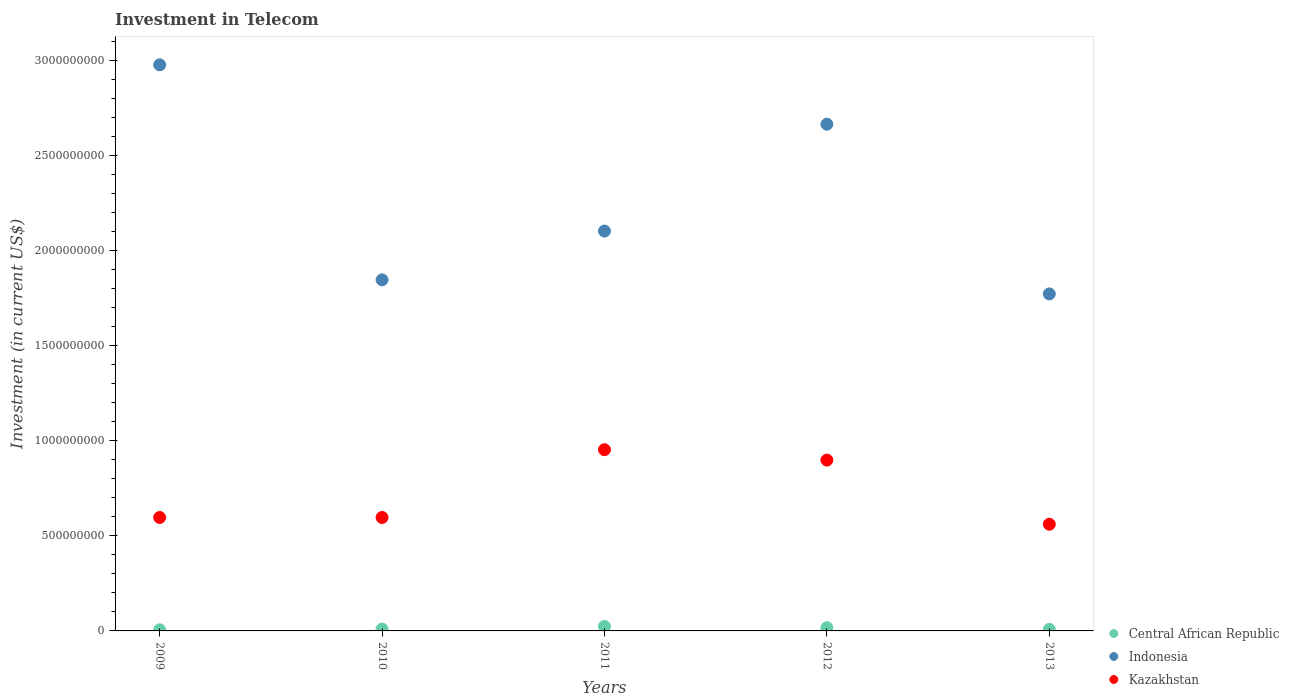Is the number of dotlines equal to the number of legend labels?
Your answer should be very brief. Yes. What is the amount invested in telecom in Central African Republic in 2012?
Offer a terse response. 1.70e+07. Across all years, what is the maximum amount invested in telecom in Central African Republic?
Provide a short and direct response. 2.39e+07. Across all years, what is the minimum amount invested in telecom in Indonesia?
Provide a short and direct response. 1.77e+09. In which year was the amount invested in telecom in Indonesia maximum?
Provide a succinct answer. 2009. In which year was the amount invested in telecom in Central African Republic minimum?
Make the answer very short. 2009. What is the total amount invested in telecom in Central African Republic in the graph?
Your answer should be compact. 6.50e+07. What is the difference between the amount invested in telecom in Central African Republic in 2010 and that in 2011?
Give a very brief answer. -1.39e+07. What is the difference between the amount invested in telecom in Indonesia in 2009 and the amount invested in telecom in Kazakhstan in 2012?
Provide a short and direct response. 2.08e+09. What is the average amount invested in telecom in Kazakhstan per year?
Your answer should be compact. 7.21e+08. In the year 2011, what is the difference between the amount invested in telecom in Kazakhstan and amount invested in telecom in Indonesia?
Your response must be concise. -1.15e+09. What is the ratio of the amount invested in telecom in Central African Republic in 2009 to that in 2011?
Make the answer very short. 0.25. Is the amount invested in telecom in Indonesia in 2012 less than that in 2013?
Keep it short and to the point. No. Is the difference between the amount invested in telecom in Kazakhstan in 2009 and 2011 greater than the difference between the amount invested in telecom in Indonesia in 2009 and 2011?
Your answer should be very brief. No. What is the difference between the highest and the second highest amount invested in telecom in Kazakhstan?
Your answer should be very brief. 5.45e+07. What is the difference between the highest and the lowest amount invested in telecom in Kazakhstan?
Your response must be concise. 3.92e+08. Is the amount invested in telecom in Kazakhstan strictly greater than the amount invested in telecom in Central African Republic over the years?
Your answer should be compact. Yes. Is the amount invested in telecom in Indonesia strictly less than the amount invested in telecom in Central African Republic over the years?
Your response must be concise. No. How many dotlines are there?
Ensure brevity in your answer.  3. Does the graph contain grids?
Make the answer very short. No. Where does the legend appear in the graph?
Offer a very short reply. Bottom right. How many legend labels are there?
Provide a short and direct response. 3. How are the legend labels stacked?
Offer a terse response. Vertical. What is the title of the graph?
Keep it short and to the point. Investment in Telecom. What is the label or title of the Y-axis?
Provide a succinct answer. Investment (in current US$). What is the Investment (in current US$) of Central African Republic in 2009?
Keep it short and to the point. 6.00e+06. What is the Investment (in current US$) in Indonesia in 2009?
Your answer should be compact. 2.98e+09. What is the Investment (in current US$) in Kazakhstan in 2009?
Give a very brief answer. 5.96e+08. What is the Investment (in current US$) of Indonesia in 2010?
Make the answer very short. 1.85e+09. What is the Investment (in current US$) of Kazakhstan in 2010?
Give a very brief answer. 5.96e+08. What is the Investment (in current US$) in Central African Republic in 2011?
Provide a short and direct response. 2.39e+07. What is the Investment (in current US$) of Indonesia in 2011?
Your answer should be compact. 2.10e+09. What is the Investment (in current US$) of Kazakhstan in 2011?
Provide a succinct answer. 9.53e+08. What is the Investment (in current US$) of Central African Republic in 2012?
Ensure brevity in your answer.  1.70e+07. What is the Investment (in current US$) of Indonesia in 2012?
Make the answer very short. 2.66e+09. What is the Investment (in current US$) of Kazakhstan in 2012?
Keep it short and to the point. 8.98e+08. What is the Investment (in current US$) of Central African Republic in 2013?
Your response must be concise. 8.10e+06. What is the Investment (in current US$) in Indonesia in 2013?
Provide a succinct answer. 1.77e+09. What is the Investment (in current US$) in Kazakhstan in 2013?
Ensure brevity in your answer.  5.61e+08. Across all years, what is the maximum Investment (in current US$) of Central African Republic?
Offer a very short reply. 2.39e+07. Across all years, what is the maximum Investment (in current US$) of Indonesia?
Your answer should be compact. 2.98e+09. Across all years, what is the maximum Investment (in current US$) of Kazakhstan?
Ensure brevity in your answer.  9.53e+08. Across all years, what is the minimum Investment (in current US$) of Central African Republic?
Offer a very short reply. 6.00e+06. Across all years, what is the minimum Investment (in current US$) in Indonesia?
Offer a very short reply. 1.77e+09. Across all years, what is the minimum Investment (in current US$) of Kazakhstan?
Provide a short and direct response. 5.61e+08. What is the total Investment (in current US$) of Central African Republic in the graph?
Your answer should be very brief. 6.50e+07. What is the total Investment (in current US$) in Indonesia in the graph?
Your answer should be very brief. 1.14e+1. What is the total Investment (in current US$) in Kazakhstan in the graph?
Your response must be concise. 3.60e+09. What is the difference between the Investment (in current US$) in Central African Republic in 2009 and that in 2010?
Make the answer very short. -4.00e+06. What is the difference between the Investment (in current US$) of Indonesia in 2009 and that in 2010?
Your answer should be very brief. 1.13e+09. What is the difference between the Investment (in current US$) in Central African Republic in 2009 and that in 2011?
Keep it short and to the point. -1.79e+07. What is the difference between the Investment (in current US$) in Indonesia in 2009 and that in 2011?
Your answer should be very brief. 8.74e+08. What is the difference between the Investment (in current US$) in Kazakhstan in 2009 and that in 2011?
Give a very brief answer. -3.56e+08. What is the difference between the Investment (in current US$) in Central African Republic in 2009 and that in 2012?
Ensure brevity in your answer.  -1.10e+07. What is the difference between the Investment (in current US$) of Indonesia in 2009 and that in 2012?
Make the answer very short. 3.12e+08. What is the difference between the Investment (in current US$) in Kazakhstan in 2009 and that in 2012?
Your answer should be very brief. -3.02e+08. What is the difference between the Investment (in current US$) of Central African Republic in 2009 and that in 2013?
Provide a succinct answer. -2.10e+06. What is the difference between the Investment (in current US$) of Indonesia in 2009 and that in 2013?
Your response must be concise. 1.20e+09. What is the difference between the Investment (in current US$) of Kazakhstan in 2009 and that in 2013?
Offer a terse response. 3.55e+07. What is the difference between the Investment (in current US$) of Central African Republic in 2010 and that in 2011?
Your answer should be very brief. -1.39e+07. What is the difference between the Investment (in current US$) of Indonesia in 2010 and that in 2011?
Offer a very short reply. -2.56e+08. What is the difference between the Investment (in current US$) in Kazakhstan in 2010 and that in 2011?
Provide a succinct answer. -3.56e+08. What is the difference between the Investment (in current US$) of Central African Republic in 2010 and that in 2012?
Ensure brevity in your answer.  -7.00e+06. What is the difference between the Investment (in current US$) in Indonesia in 2010 and that in 2012?
Make the answer very short. -8.18e+08. What is the difference between the Investment (in current US$) of Kazakhstan in 2010 and that in 2012?
Ensure brevity in your answer.  -3.02e+08. What is the difference between the Investment (in current US$) in Central African Republic in 2010 and that in 2013?
Give a very brief answer. 1.90e+06. What is the difference between the Investment (in current US$) of Indonesia in 2010 and that in 2013?
Your answer should be compact. 7.40e+07. What is the difference between the Investment (in current US$) of Kazakhstan in 2010 and that in 2013?
Keep it short and to the point. 3.55e+07. What is the difference between the Investment (in current US$) in Central African Republic in 2011 and that in 2012?
Provide a succinct answer. 6.90e+06. What is the difference between the Investment (in current US$) of Indonesia in 2011 and that in 2012?
Your response must be concise. -5.62e+08. What is the difference between the Investment (in current US$) of Kazakhstan in 2011 and that in 2012?
Your response must be concise. 5.45e+07. What is the difference between the Investment (in current US$) in Central African Republic in 2011 and that in 2013?
Offer a terse response. 1.58e+07. What is the difference between the Investment (in current US$) of Indonesia in 2011 and that in 2013?
Give a very brief answer. 3.30e+08. What is the difference between the Investment (in current US$) of Kazakhstan in 2011 and that in 2013?
Your answer should be very brief. 3.92e+08. What is the difference between the Investment (in current US$) in Central African Republic in 2012 and that in 2013?
Your answer should be very brief. 8.90e+06. What is the difference between the Investment (in current US$) in Indonesia in 2012 and that in 2013?
Your answer should be very brief. 8.92e+08. What is the difference between the Investment (in current US$) of Kazakhstan in 2012 and that in 2013?
Your answer should be compact. 3.37e+08. What is the difference between the Investment (in current US$) in Central African Republic in 2009 and the Investment (in current US$) in Indonesia in 2010?
Give a very brief answer. -1.84e+09. What is the difference between the Investment (in current US$) of Central African Republic in 2009 and the Investment (in current US$) of Kazakhstan in 2010?
Make the answer very short. -5.90e+08. What is the difference between the Investment (in current US$) in Indonesia in 2009 and the Investment (in current US$) in Kazakhstan in 2010?
Provide a short and direct response. 2.38e+09. What is the difference between the Investment (in current US$) in Central African Republic in 2009 and the Investment (in current US$) in Indonesia in 2011?
Provide a succinct answer. -2.10e+09. What is the difference between the Investment (in current US$) of Central African Republic in 2009 and the Investment (in current US$) of Kazakhstan in 2011?
Offer a very short reply. -9.47e+08. What is the difference between the Investment (in current US$) in Indonesia in 2009 and the Investment (in current US$) in Kazakhstan in 2011?
Offer a terse response. 2.02e+09. What is the difference between the Investment (in current US$) of Central African Republic in 2009 and the Investment (in current US$) of Indonesia in 2012?
Ensure brevity in your answer.  -2.66e+09. What is the difference between the Investment (in current US$) of Central African Republic in 2009 and the Investment (in current US$) of Kazakhstan in 2012?
Your response must be concise. -8.92e+08. What is the difference between the Investment (in current US$) of Indonesia in 2009 and the Investment (in current US$) of Kazakhstan in 2012?
Make the answer very short. 2.08e+09. What is the difference between the Investment (in current US$) of Central African Republic in 2009 and the Investment (in current US$) of Indonesia in 2013?
Your response must be concise. -1.77e+09. What is the difference between the Investment (in current US$) of Central African Republic in 2009 and the Investment (in current US$) of Kazakhstan in 2013?
Keep it short and to the point. -5.55e+08. What is the difference between the Investment (in current US$) of Indonesia in 2009 and the Investment (in current US$) of Kazakhstan in 2013?
Provide a succinct answer. 2.42e+09. What is the difference between the Investment (in current US$) of Central African Republic in 2010 and the Investment (in current US$) of Indonesia in 2011?
Provide a short and direct response. -2.09e+09. What is the difference between the Investment (in current US$) in Central African Republic in 2010 and the Investment (in current US$) in Kazakhstan in 2011?
Your answer should be very brief. -9.43e+08. What is the difference between the Investment (in current US$) in Indonesia in 2010 and the Investment (in current US$) in Kazakhstan in 2011?
Ensure brevity in your answer.  8.93e+08. What is the difference between the Investment (in current US$) of Central African Republic in 2010 and the Investment (in current US$) of Indonesia in 2012?
Provide a succinct answer. -2.65e+09. What is the difference between the Investment (in current US$) in Central African Republic in 2010 and the Investment (in current US$) in Kazakhstan in 2012?
Give a very brief answer. -8.88e+08. What is the difference between the Investment (in current US$) of Indonesia in 2010 and the Investment (in current US$) of Kazakhstan in 2012?
Your response must be concise. 9.47e+08. What is the difference between the Investment (in current US$) in Central African Republic in 2010 and the Investment (in current US$) in Indonesia in 2013?
Make the answer very short. -1.76e+09. What is the difference between the Investment (in current US$) of Central African Republic in 2010 and the Investment (in current US$) of Kazakhstan in 2013?
Offer a terse response. -5.51e+08. What is the difference between the Investment (in current US$) in Indonesia in 2010 and the Investment (in current US$) in Kazakhstan in 2013?
Give a very brief answer. 1.28e+09. What is the difference between the Investment (in current US$) of Central African Republic in 2011 and the Investment (in current US$) of Indonesia in 2012?
Your answer should be compact. -2.64e+09. What is the difference between the Investment (in current US$) of Central African Republic in 2011 and the Investment (in current US$) of Kazakhstan in 2012?
Ensure brevity in your answer.  -8.74e+08. What is the difference between the Investment (in current US$) of Indonesia in 2011 and the Investment (in current US$) of Kazakhstan in 2012?
Keep it short and to the point. 1.20e+09. What is the difference between the Investment (in current US$) of Central African Republic in 2011 and the Investment (in current US$) of Indonesia in 2013?
Your answer should be very brief. -1.75e+09. What is the difference between the Investment (in current US$) in Central African Republic in 2011 and the Investment (in current US$) in Kazakhstan in 2013?
Make the answer very short. -5.37e+08. What is the difference between the Investment (in current US$) of Indonesia in 2011 and the Investment (in current US$) of Kazakhstan in 2013?
Make the answer very short. 1.54e+09. What is the difference between the Investment (in current US$) in Central African Republic in 2012 and the Investment (in current US$) in Indonesia in 2013?
Ensure brevity in your answer.  -1.75e+09. What is the difference between the Investment (in current US$) in Central African Republic in 2012 and the Investment (in current US$) in Kazakhstan in 2013?
Offer a very short reply. -5.44e+08. What is the difference between the Investment (in current US$) of Indonesia in 2012 and the Investment (in current US$) of Kazakhstan in 2013?
Your answer should be compact. 2.10e+09. What is the average Investment (in current US$) of Central African Republic per year?
Offer a terse response. 1.30e+07. What is the average Investment (in current US$) of Indonesia per year?
Your answer should be very brief. 2.27e+09. What is the average Investment (in current US$) of Kazakhstan per year?
Your answer should be compact. 7.21e+08. In the year 2009, what is the difference between the Investment (in current US$) in Central African Republic and Investment (in current US$) in Indonesia?
Your response must be concise. -2.97e+09. In the year 2009, what is the difference between the Investment (in current US$) in Central African Republic and Investment (in current US$) in Kazakhstan?
Ensure brevity in your answer.  -5.90e+08. In the year 2009, what is the difference between the Investment (in current US$) in Indonesia and Investment (in current US$) in Kazakhstan?
Give a very brief answer. 2.38e+09. In the year 2010, what is the difference between the Investment (in current US$) of Central African Republic and Investment (in current US$) of Indonesia?
Offer a terse response. -1.84e+09. In the year 2010, what is the difference between the Investment (in current US$) in Central African Republic and Investment (in current US$) in Kazakhstan?
Keep it short and to the point. -5.86e+08. In the year 2010, what is the difference between the Investment (in current US$) in Indonesia and Investment (in current US$) in Kazakhstan?
Provide a succinct answer. 1.25e+09. In the year 2011, what is the difference between the Investment (in current US$) of Central African Republic and Investment (in current US$) of Indonesia?
Make the answer very short. -2.08e+09. In the year 2011, what is the difference between the Investment (in current US$) in Central African Republic and Investment (in current US$) in Kazakhstan?
Make the answer very short. -9.29e+08. In the year 2011, what is the difference between the Investment (in current US$) in Indonesia and Investment (in current US$) in Kazakhstan?
Ensure brevity in your answer.  1.15e+09. In the year 2012, what is the difference between the Investment (in current US$) in Central African Republic and Investment (in current US$) in Indonesia?
Make the answer very short. -2.65e+09. In the year 2012, what is the difference between the Investment (in current US$) in Central African Republic and Investment (in current US$) in Kazakhstan?
Give a very brief answer. -8.81e+08. In the year 2012, what is the difference between the Investment (in current US$) of Indonesia and Investment (in current US$) of Kazakhstan?
Give a very brief answer. 1.77e+09. In the year 2013, what is the difference between the Investment (in current US$) in Central African Republic and Investment (in current US$) in Indonesia?
Provide a short and direct response. -1.76e+09. In the year 2013, what is the difference between the Investment (in current US$) of Central African Republic and Investment (in current US$) of Kazakhstan?
Keep it short and to the point. -5.53e+08. In the year 2013, what is the difference between the Investment (in current US$) in Indonesia and Investment (in current US$) in Kazakhstan?
Ensure brevity in your answer.  1.21e+09. What is the ratio of the Investment (in current US$) in Indonesia in 2009 to that in 2010?
Offer a very short reply. 1.61. What is the ratio of the Investment (in current US$) of Kazakhstan in 2009 to that in 2010?
Give a very brief answer. 1. What is the ratio of the Investment (in current US$) of Central African Republic in 2009 to that in 2011?
Ensure brevity in your answer.  0.25. What is the ratio of the Investment (in current US$) in Indonesia in 2009 to that in 2011?
Keep it short and to the point. 1.42. What is the ratio of the Investment (in current US$) in Kazakhstan in 2009 to that in 2011?
Your response must be concise. 0.63. What is the ratio of the Investment (in current US$) in Central African Republic in 2009 to that in 2012?
Your response must be concise. 0.35. What is the ratio of the Investment (in current US$) of Indonesia in 2009 to that in 2012?
Give a very brief answer. 1.12. What is the ratio of the Investment (in current US$) in Kazakhstan in 2009 to that in 2012?
Offer a terse response. 0.66. What is the ratio of the Investment (in current US$) of Central African Republic in 2009 to that in 2013?
Make the answer very short. 0.74. What is the ratio of the Investment (in current US$) in Indonesia in 2009 to that in 2013?
Ensure brevity in your answer.  1.68. What is the ratio of the Investment (in current US$) of Kazakhstan in 2009 to that in 2013?
Provide a short and direct response. 1.06. What is the ratio of the Investment (in current US$) of Central African Republic in 2010 to that in 2011?
Keep it short and to the point. 0.42. What is the ratio of the Investment (in current US$) in Indonesia in 2010 to that in 2011?
Provide a succinct answer. 0.88. What is the ratio of the Investment (in current US$) of Kazakhstan in 2010 to that in 2011?
Provide a succinct answer. 0.63. What is the ratio of the Investment (in current US$) of Central African Republic in 2010 to that in 2012?
Offer a terse response. 0.59. What is the ratio of the Investment (in current US$) in Indonesia in 2010 to that in 2012?
Provide a short and direct response. 0.69. What is the ratio of the Investment (in current US$) in Kazakhstan in 2010 to that in 2012?
Offer a terse response. 0.66. What is the ratio of the Investment (in current US$) in Central African Republic in 2010 to that in 2013?
Make the answer very short. 1.23. What is the ratio of the Investment (in current US$) in Indonesia in 2010 to that in 2013?
Provide a succinct answer. 1.04. What is the ratio of the Investment (in current US$) of Kazakhstan in 2010 to that in 2013?
Make the answer very short. 1.06. What is the ratio of the Investment (in current US$) of Central African Republic in 2011 to that in 2012?
Provide a succinct answer. 1.41. What is the ratio of the Investment (in current US$) of Indonesia in 2011 to that in 2012?
Make the answer very short. 0.79. What is the ratio of the Investment (in current US$) in Kazakhstan in 2011 to that in 2012?
Your response must be concise. 1.06. What is the ratio of the Investment (in current US$) in Central African Republic in 2011 to that in 2013?
Your response must be concise. 2.95. What is the ratio of the Investment (in current US$) of Indonesia in 2011 to that in 2013?
Give a very brief answer. 1.19. What is the ratio of the Investment (in current US$) in Kazakhstan in 2011 to that in 2013?
Provide a short and direct response. 1.7. What is the ratio of the Investment (in current US$) in Central African Republic in 2012 to that in 2013?
Make the answer very short. 2.1. What is the ratio of the Investment (in current US$) of Indonesia in 2012 to that in 2013?
Give a very brief answer. 1.5. What is the ratio of the Investment (in current US$) in Kazakhstan in 2012 to that in 2013?
Ensure brevity in your answer.  1.6. What is the difference between the highest and the second highest Investment (in current US$) in Central African Republic?
Your answer should be compact. 6.90e+06. What is the difference between the highest and the second highest Investment (in current US$) of Indonesia?
Provide a short and direct response. 3.12e+08. What is the difference between the highest and the second highest Investment (in current US$) of Kazakhstan?
Your answer should be very brief. 5.45e+07. What is the difference between the highest and the lowest Investment (in current US$) of Central African Republic?
Offer a terse response. 1.79e+07. What is the difference between the highest and the lowest Investment (in current US$) of Indonesia?
Your answer should be compact. 1.20e+09. What is the difference between the highest and the lowest Investment (in current US$) in Kazakhstan?
Provide a succinct answer. 3.92e+08. 